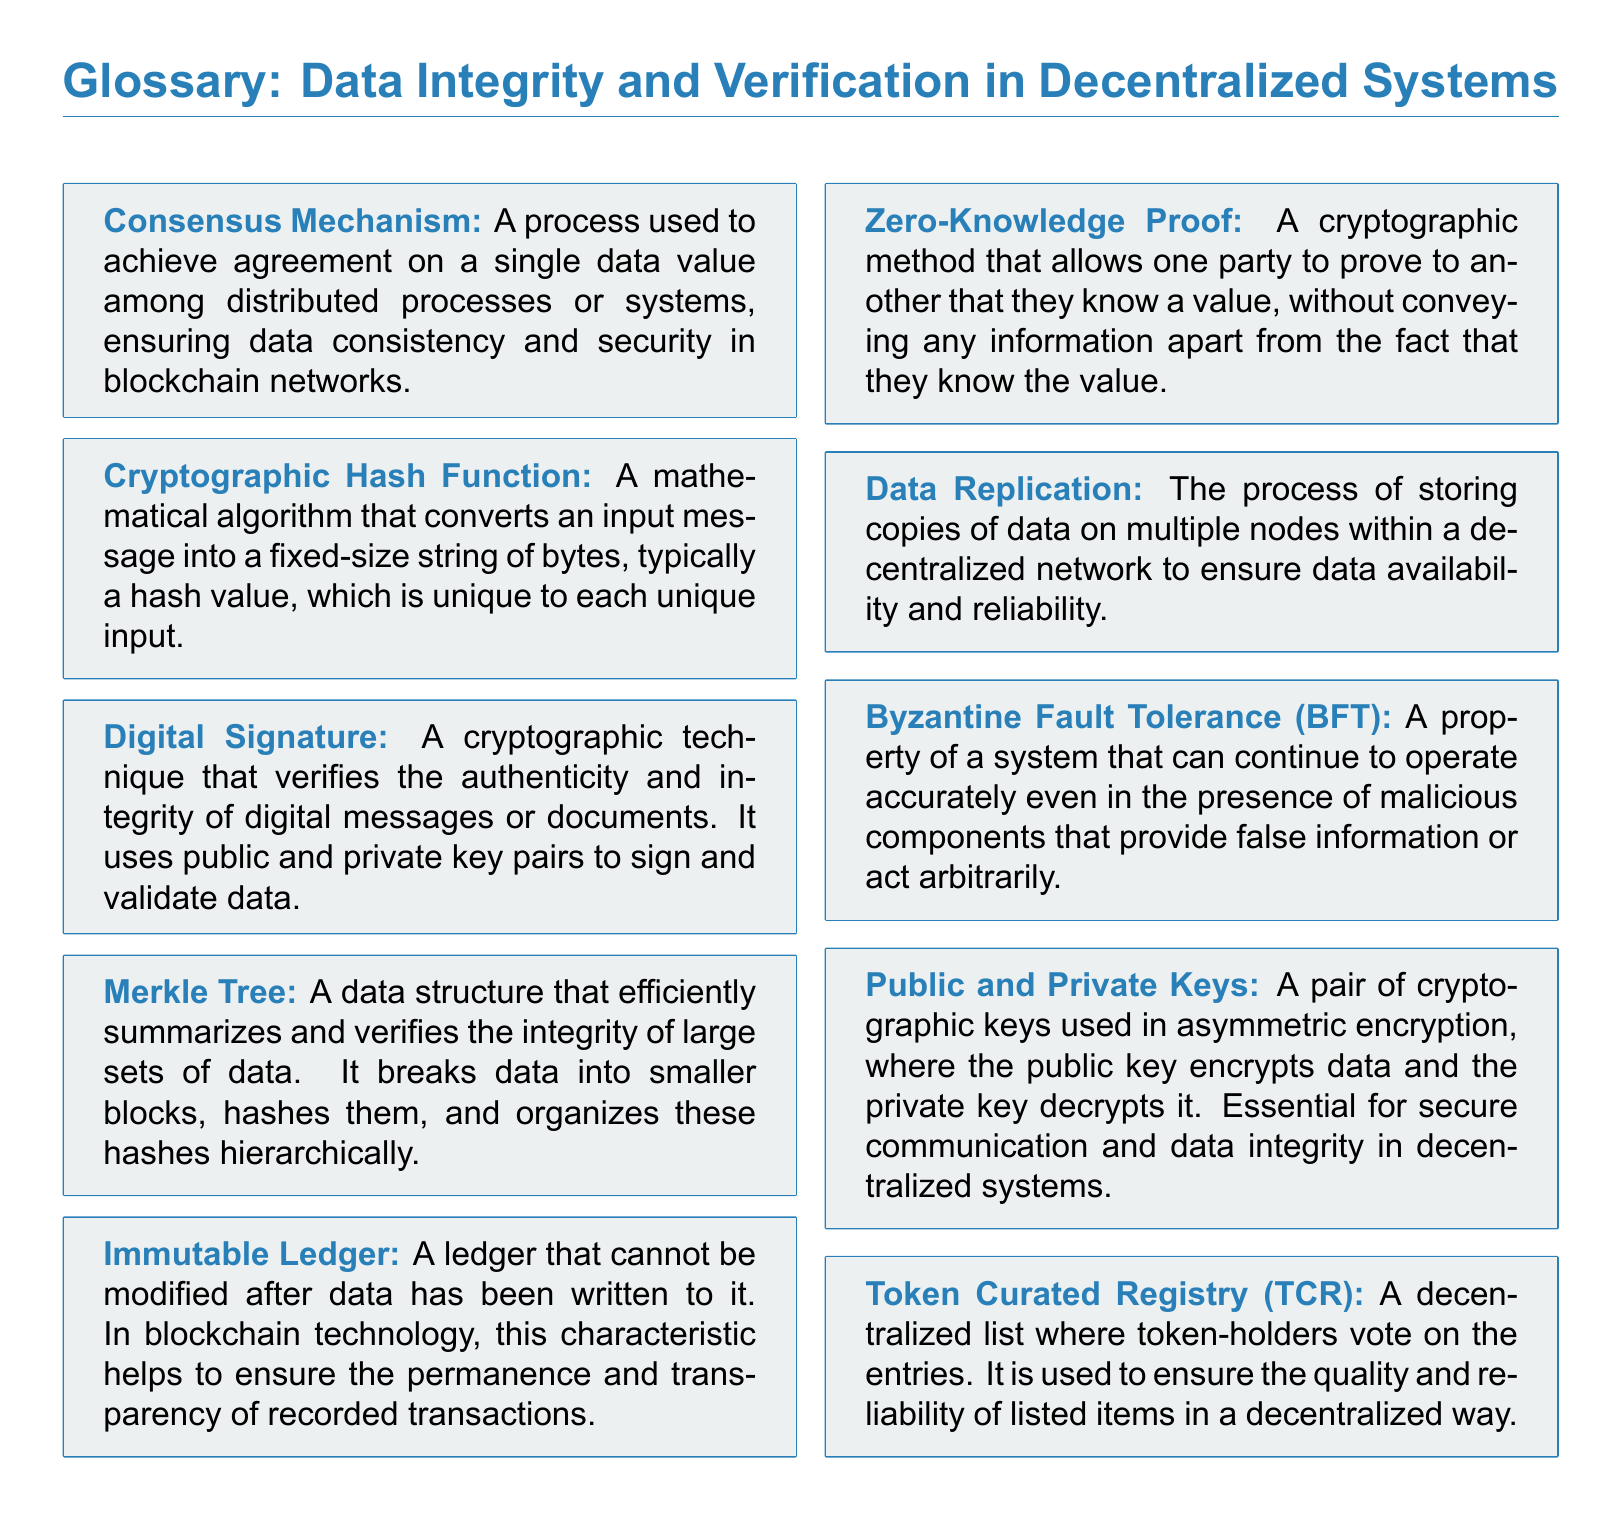What is a Consensus Mechanism? A Consensus Mechanism is a process used to achieve agreement on a single data value among distributed processes or systems, ensuring data consistency and security in blockchain networks.
Answer: A process used to achieve agreement on a single data value What does a Cryptographic Hash Function do? A Cryptographic Hash Function converts an input message into a fixed-size string of bytes, typically a hash value, which is unique to each unique input.
Answer: Converts an input message into a fixed-size string What is the role of a Digital Signature? A Digital Signature verifies the authenticity and integrity of digital messages or documents using public and private key pairs.
Answer: Verifies authenticity and integrity of digital messages What is a Merkle Tree? A Merkle Tree is a data structure that efficiently summarizes and verifies the integrity of large sets of data by breaking data into smaller blocks, hashing them, and organizing these hashes hierarchically.
Answer: A data structure that summarizes and verifies integrity What is an Immutable Ledger? An Immutable Ledger is a ledger that cannot be modified after data has been written to it, ensuring permanence and transparency of recorded transactions.
Answer: A ledger that cannot be modified What is Byzantine Fault Tolerance (BFT)? Byzantine Fault Tolerance (BFT) is a property of a system that can continue to operate accurately even with malicious components providing false information.
Answer: A property that allows continued accurate operation What are Public and Private Keys used for? Public and Private Keys are used in asymmetric encryption where the public key encrypts data and the private key decrypts it, ensuring secure communication and data integrity.
Answer: Used in asymmetric encryption for secure communication How does Data Replication work? Data Replication is the process of storing copies of data on multiple nodes within a decentralized network to ensure data availability and reliability.
Answer: Storing copies of data on multiple nodes What does a Token Curated Registry (TCR) do? A Token Curated Registry (TCR) is a decentralized list where token-holders vote on the entries to ensure the quality and reliability of listed items.
Answer: A decentralized list voted on by token-holders 